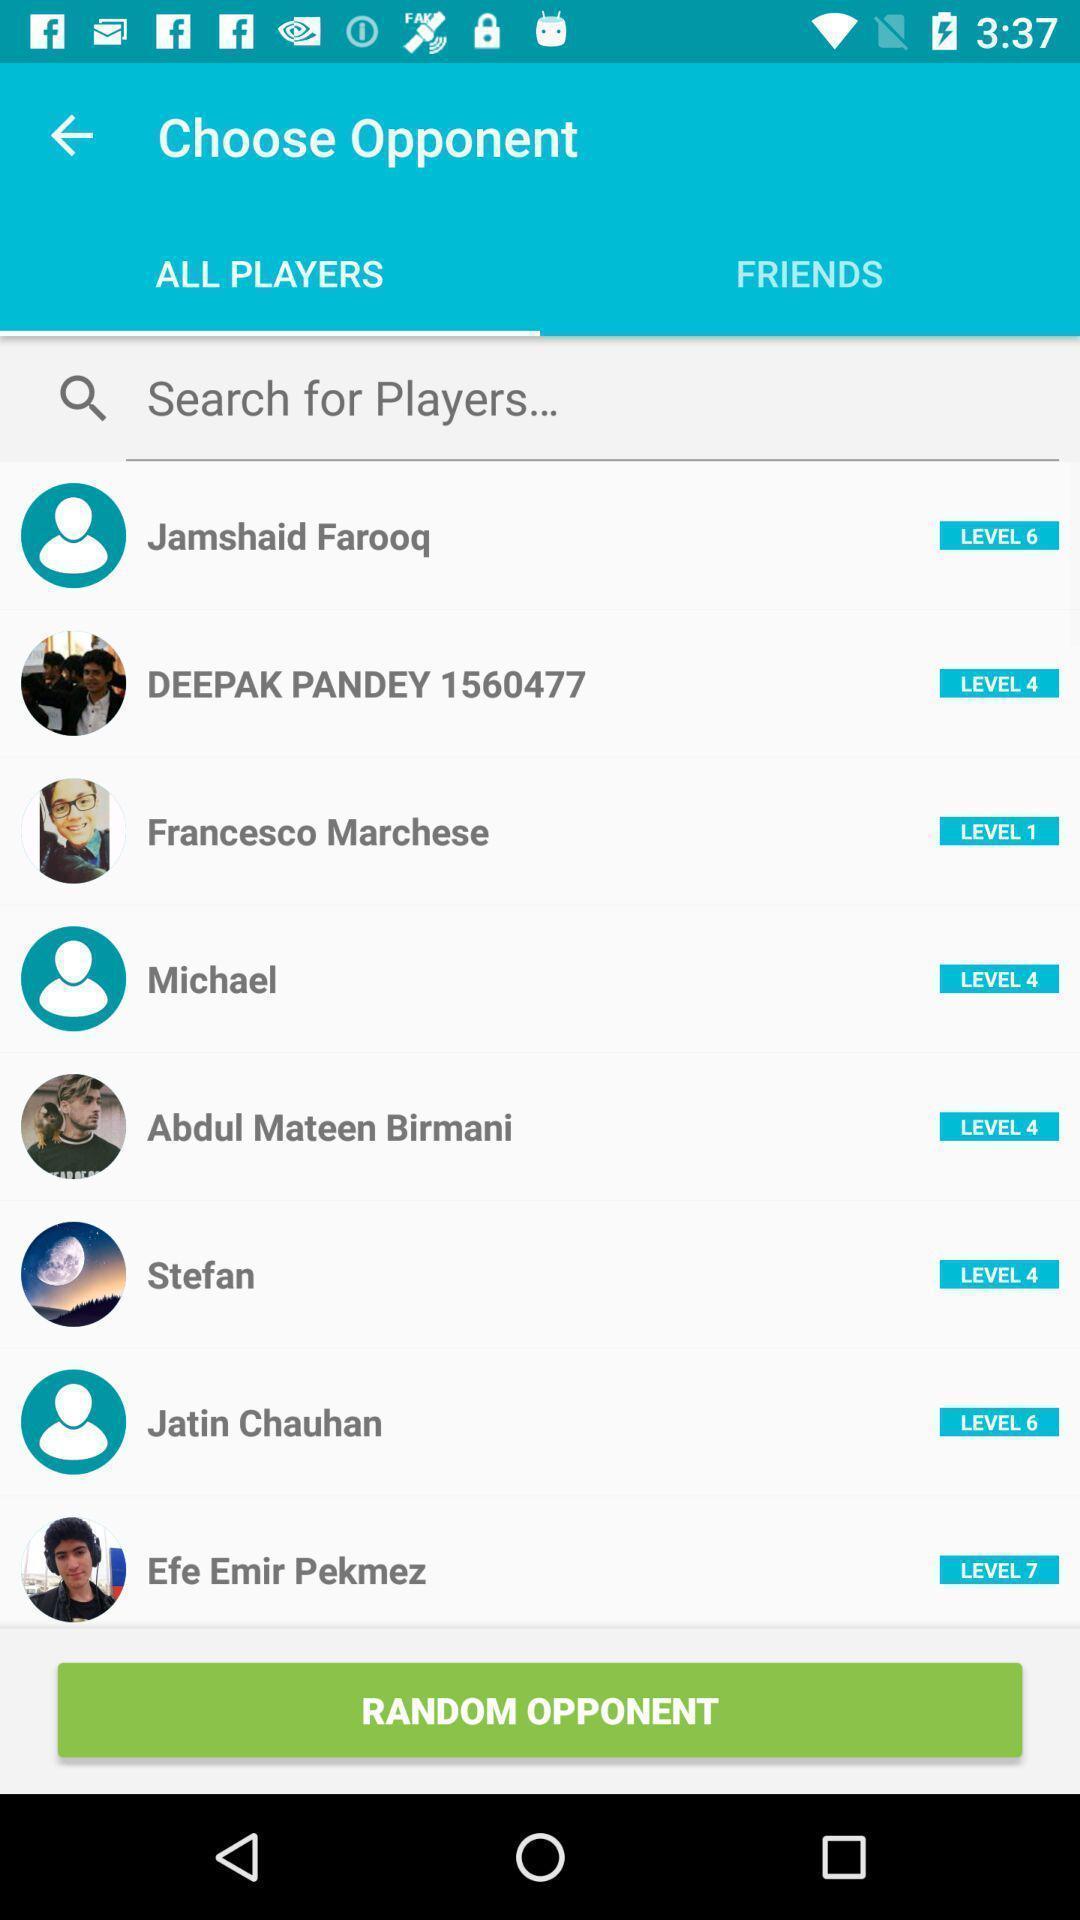Tell me what you see in this picture. Screen showing list of all players to choose opponent. 